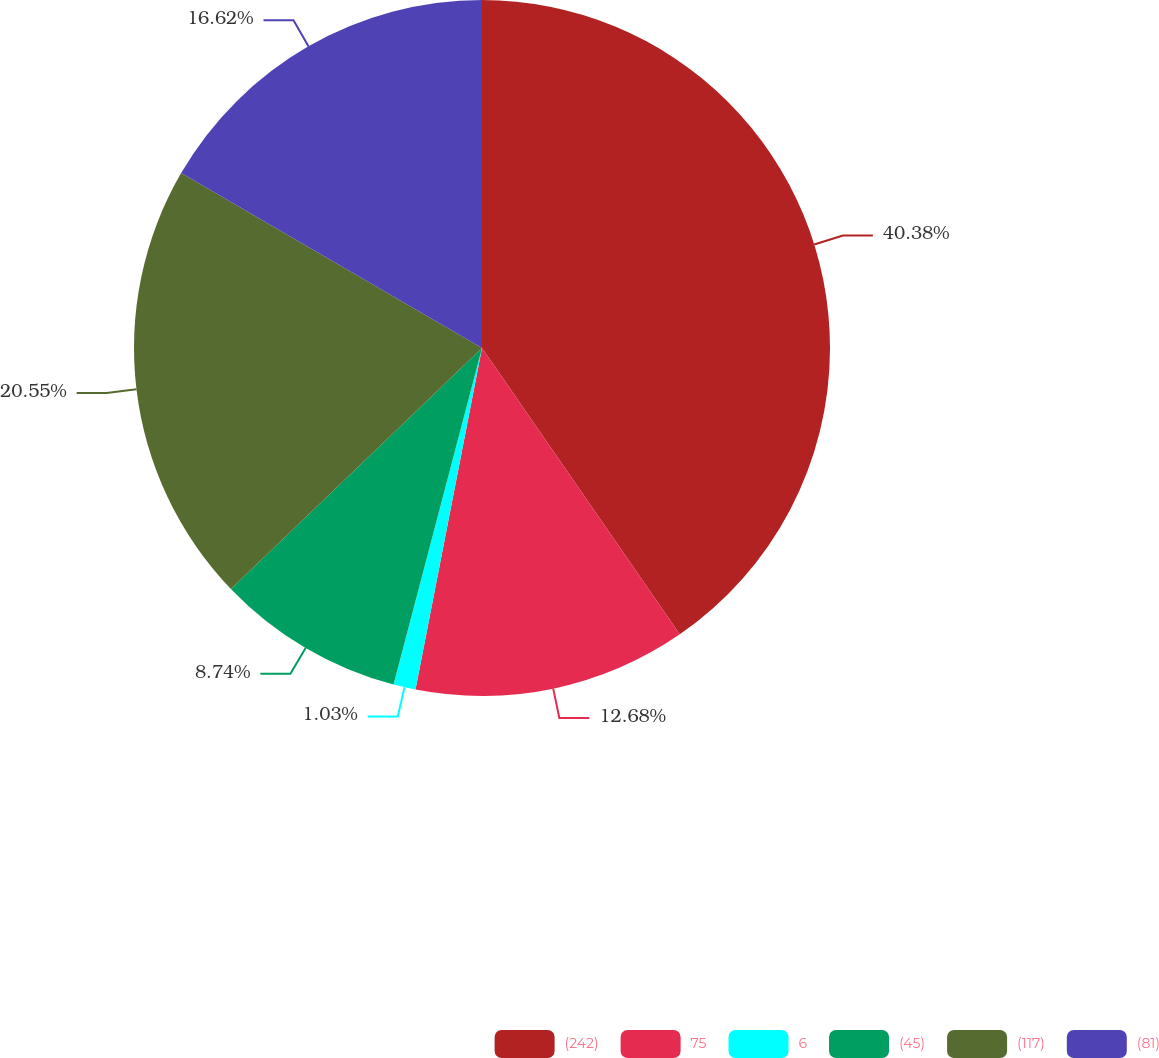<chart> <loc_0><loc_0><loc_500><loc_500><pie_chart><fcel>(242)<fcel>75<fcel>6<fcel>(45)<fcel>(117)<fcel>(81)<nl><fcel>40.38%<fcel>12.68%<fcel>1.03%<fcel>8.74%<fcel>20.55%<fcel>16.62%<nl></chart> 